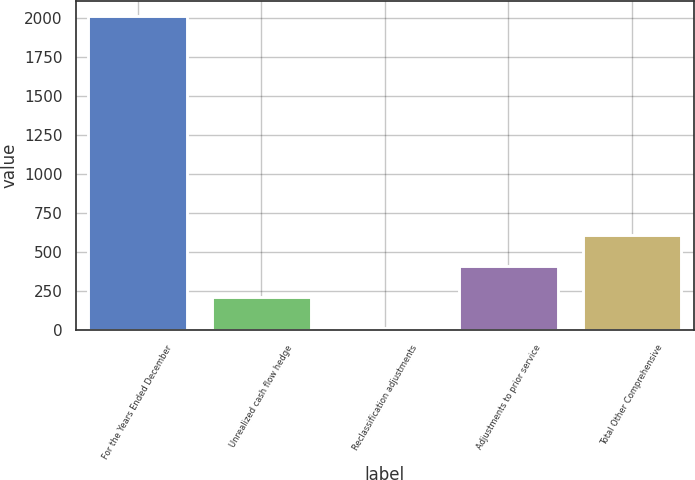<chart> <loc_0><loc_0><loc_500><loc_500><bar_chart><fcel>For the Years Ended December<fcel>Unrealized cash flow hedge<fcel>Reclassification adjustments<fcel>Adjustments to prior service<fcel>Total Other Comprehensive<nl><fcel>2012<fcel>212.18<fcel>12.2<fcel>412.16<fcel>612.14<nl></chart> 